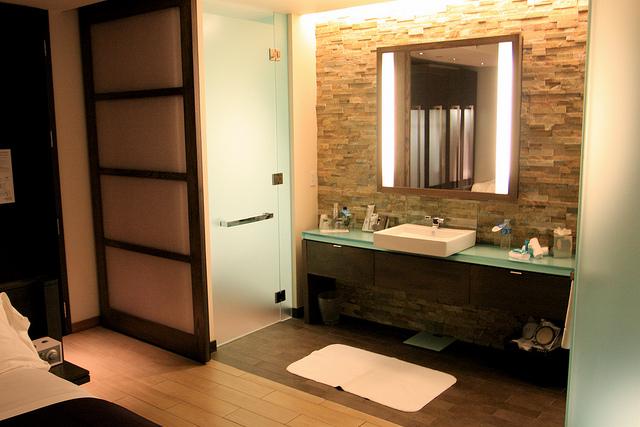Is this a bathroom alone?
Keep it brief. No. Can anyone be seen taking a shower?
Keep it brief. No. Is this a clean bathroom?
Be succinct. Yes. What is hanging on the wall?
Write a very short answer. Mirror. 